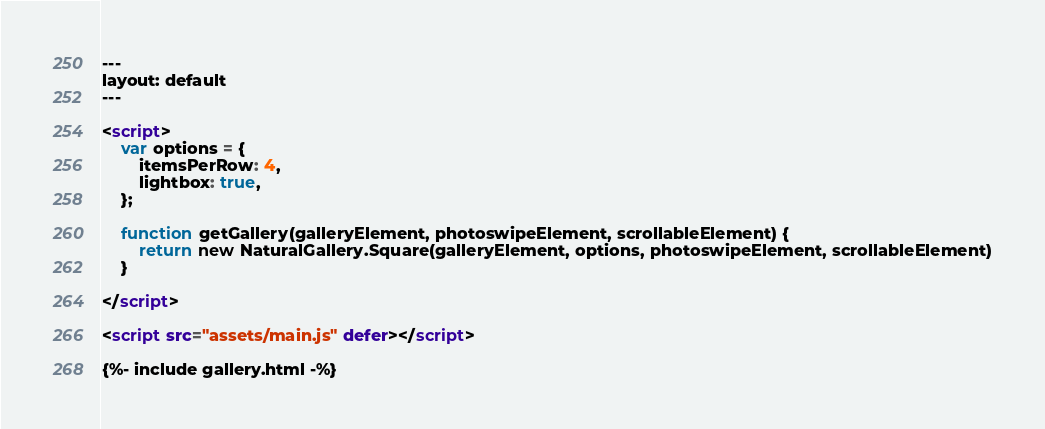<code> <loc_0><loc_0><loc_500><loc_500><_HTML_>---
layout: default
---

<script>
    var options = {
        itemsPerRow: 4,
        lightbox: true,
    };

    function getGallery(galleryElement, photoswipeElement, scrollableElement) {
        return new NaturalGallery.Square(galleryElement, options, photoswipeElement, scrollableElement)
    }

</script>

<script src="assets/main.js" defer></script>

{%- include gallery.html -%}
</code> 